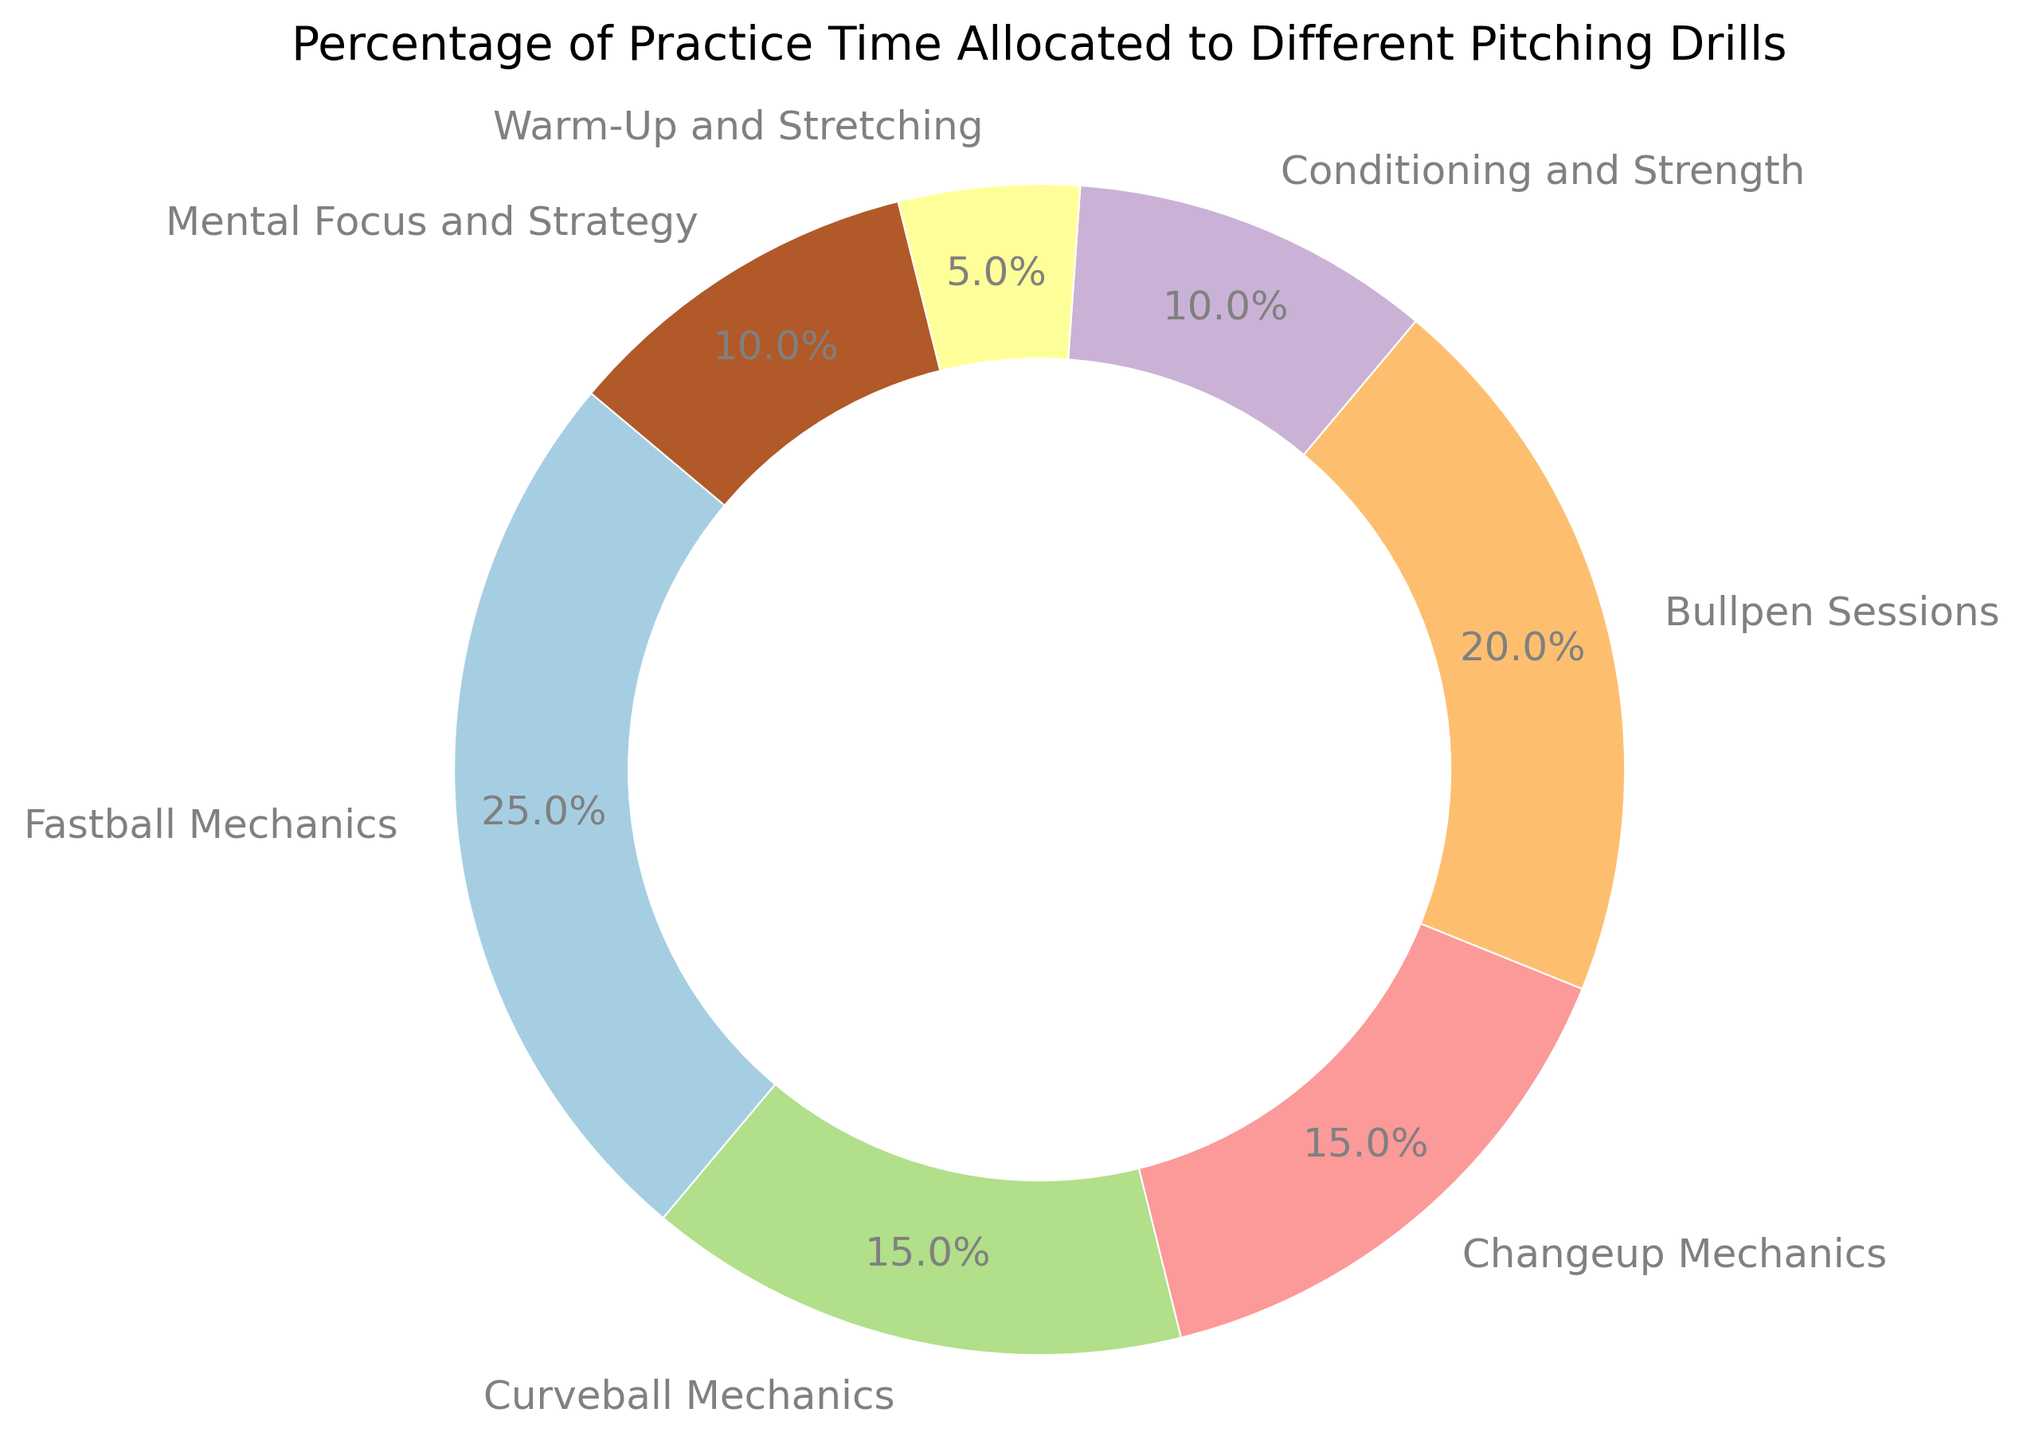Which drill occupies the highest percentage of practice time? The ring chart shows that "Fastball Mechanics" has the largest segment. This visual observation indicates that "Fastball Mechanics" has the highest percentage of practice time.
Answer: Fastball Mechanics What percentage of practice time is dedicated to Bullpen Sessions and Mental Focus and Strategy combined? From the chart, Bullpen Sessions take up 20% and Mental Focus and Strategy take up 10%. Summing these percentages: 20% + 10% = 30%.
Answer: 30% How does the percentage of time spent on Curveball Mechanics compare to Changeup Mechanics? Both Curveball Mechanics and Changeup Mechanics occupy equal portions of the ring chart. Each is labeled with 15%, indicating equal practice time allocation.
Answer: Equal What is the difference in the percentage of practice time between Fastball Mechanics and Conditioning and Strength? Fastball Mechanics takes up 25%, while Conditioning and Strength takes up 10%. The difference is calculated as: 25% - 10% = 15%.
Answer: 15% Is more time allocated to Warm-Up and Stretching or Mental Focus and Strategy? The chart shows that Warm-Up and Stretching accounts for 5%, while Mental Focus and Strategy accounts for 10%. Comparing the two: 10% (Mental Focus and Strategy) > 5% (Warm-Up and Stretching).
Answer: Mental Focus and Strategy Calculate the total percentage of practice time allocated to all types of mechanics (Fastball, Curveball, Changeup). The ring chart labels highlight that Fastball Mechanics is 25%, Curveball Mechanics is 15%, and Changeup Mechanics is 15%. Summing these values: 25% + 15% + 15% = 55%.
Answer: 55% Which drill has the smallest allocated percentage of practice time and what is that percentage? The smallest segment in the ring chart is for Warm-Up and Stretching, which is labeled with 5%.
Answer: Warm-Up and Stretching, 5% Among the drills, which two allocations combined equal the percentage allocated to Fastball Mechanics? Fastball Mechanics is allocated 25%. The chart shows that both Curveball Mechanics and Changeup Mechanics are 15% each, and combining 15% (Curveball) + 10% (Conditioning and Strength) equals 25%.
Answer: Curveball Mechanics and Conditioning and Strength 